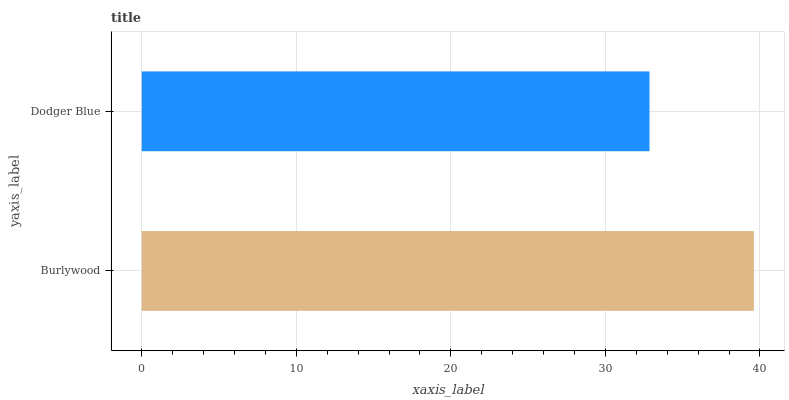Is Dodger Blue the minimum?
Answer yes or no. Yes. Is Burlywood the maximum?
Answer yes or no. Yes. Is Dodger Blue the maximum?
Answer yes or no. No. Is Burlywood greater than Dodger Blue?
Answer yes or no. Yes. Is Dodger Blue less than Burlywood?
Answer yes or no. Yes. Is Dodger Blue greater than Burlywood?
Answer yes or no. No. Is Burlywood less than Dodger Blue?
Answer yes or no. No. Is Burlywood the high median?
Answer yes or no. Yes. Is Dodger Blue the low median?
Answer yes or no. Yes. Is Dodger Blue the high median?
Answer yes or no. No. Is Burlywood the low median?
Answer yes or no. No. 